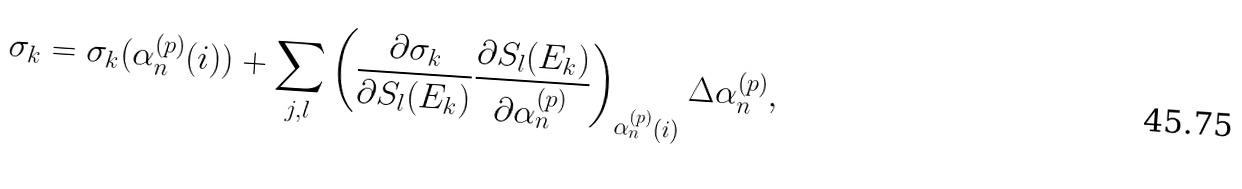Convert formula to latex. <formula><loc_0><loc_0><loc_500><loc_500>\sigma _ { k } = \sigma _ { k } ( \alpha ^ { ( p ) } _ { n } ( i ) ) + \sum _ { j , l } \left ( \frac { \partial \sigma _ { k } } { \partial S _ { l } ( E _ { k } ) } \frac { \partial S _ { l } ( E _ { k } ) } { \partial \alpha ^ { ( p ) } _ { n } } \right ) _ { \alpha ^ { ( p ) } _ { n } ( i ) } \Delta \alpha ^ { ( p ) } _ { n } ,</formula> 